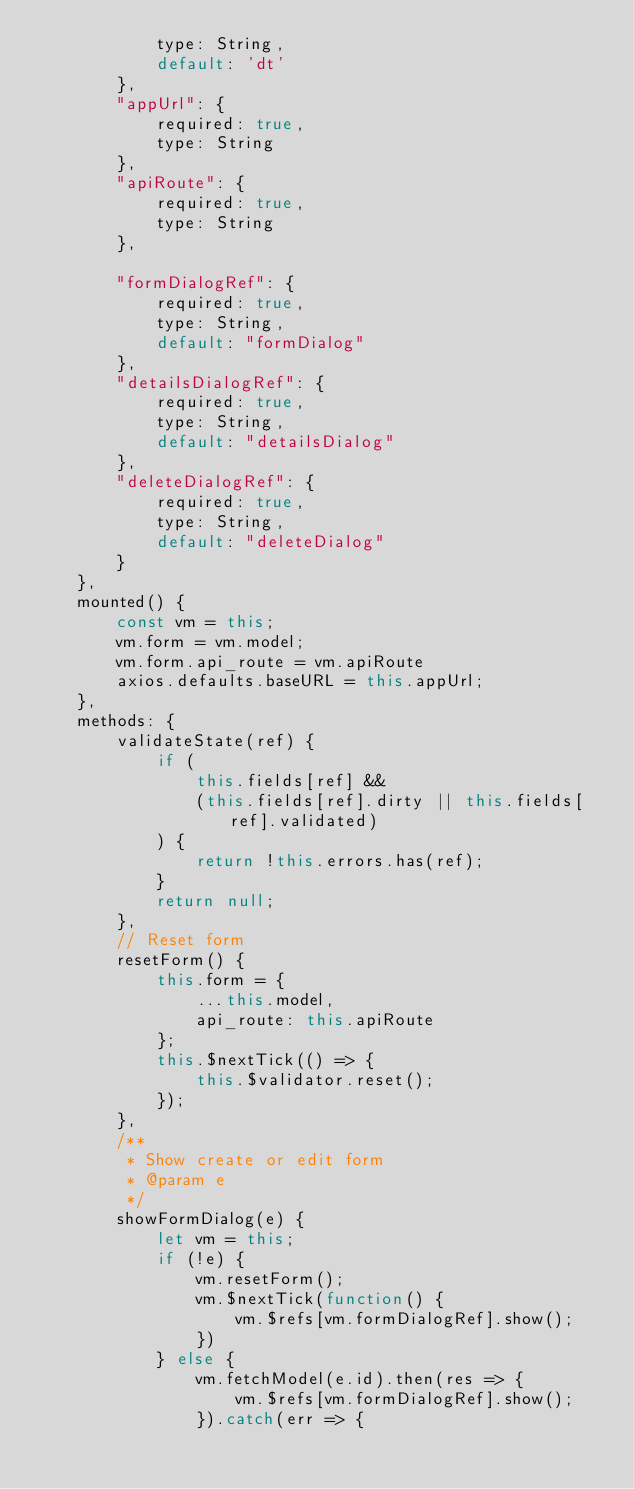Convert code to text. <code><loc_0><loc_0><loc_500><loc_500><_JavaScript_>            type: String,
            default: 'dt'
        },
        "appUrl": {
            required: true,
            type: String
        },
        "apiRoute": {
            required: true,
            type: String
        },

        "formDialogRef": {
            required: true,
            type: String,
            default: "formDialog"
        },
        "detailsDialogRef": {
            required: true,
            type: String,
            default: "detailsDialog"
        },
        "deleteDialogRef": {
            required: true,
            type: String,
            default: "deleteDialog"
        }
    },
    mounted() {
        const vm = this;
        vm.form = vm.model;
        vm.form.api_route = vm.apiRoute
        axios.defaults.baseURL = this.appUrl;
    },
    methods: {
        validateState(ref) {
            if (
                this.fields[ref] &&
                (this.fields[ref].dirty || this.fields[ref].validated)
            ) {
                return !this.errors.has(ref);
            }
            return null;
        },
        // Reset form
        resetForm() {
            this.form = {
                ...this.model,
                api_route: this.apiRoute
            };
            this.$nextTick(() => {
                this.$validator.reset();
            });
        },
        /**
         * Show create or edit form
         * @param e
         */
        showFormDialog(e) {
            let vm = this;
            if (!e) {
                vm.resetForm();
                vm.$nextTick(function() {
                    vm.$refs[vm.formDialogRef].show();
                })
            } else {
                vm.fetchModel(e.id).then(res => {
                    vm.$refs[vm.formDialogRef].show();
                }).catch(err => {</code> 